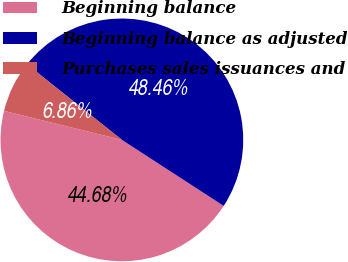Convert chart to OTSL. <chart><loc_0><loc_0><loc_500><loc_500><pie_chart><fcel>Beginning balance<fcel>Beginning balance as adjusted<fcel>Purchases sales issuances and<nl><fcel>44.68%<fcel>48.46%<fcel>6.86%<nl></chart> 